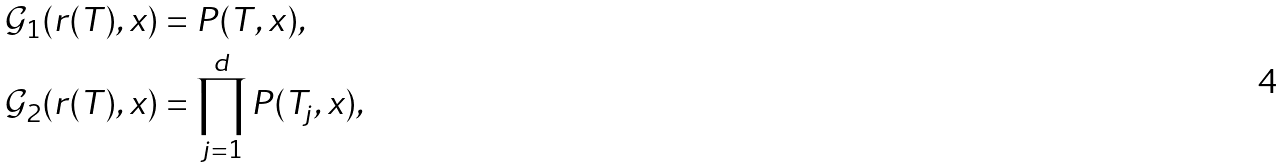Convert formula to latex. <formula><loc_0><loc_0><loc_500><loc_500>\mathcal { G } _ { 1 } ( r ( T ) , x ) & = P ( T , x ) , \\ \mathcal { G } _ { 2 } ( r ( T ) , x ) & = \prod _ { j = 1 } ^ { d } P ( T _ { j } , x ) ,</formula> 